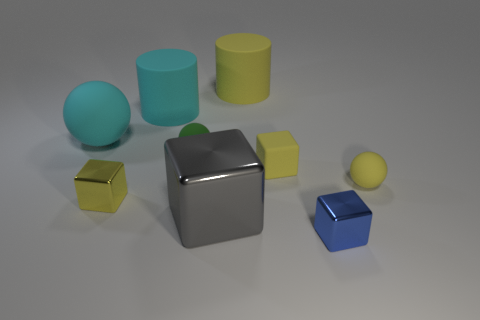Subtract all blocks. How many objects are left? 5 Add 8 gray objects. How many gray objects exist? 9 Subtract 1 yellow cubes. How many objects are left? 8 Subtract all tiny yellow shiny blocks. Subtract all small yellow rubber balls. How many objects are left? 7 Add 1 rubber cylinders. How many rubber cylinders are left? 3 